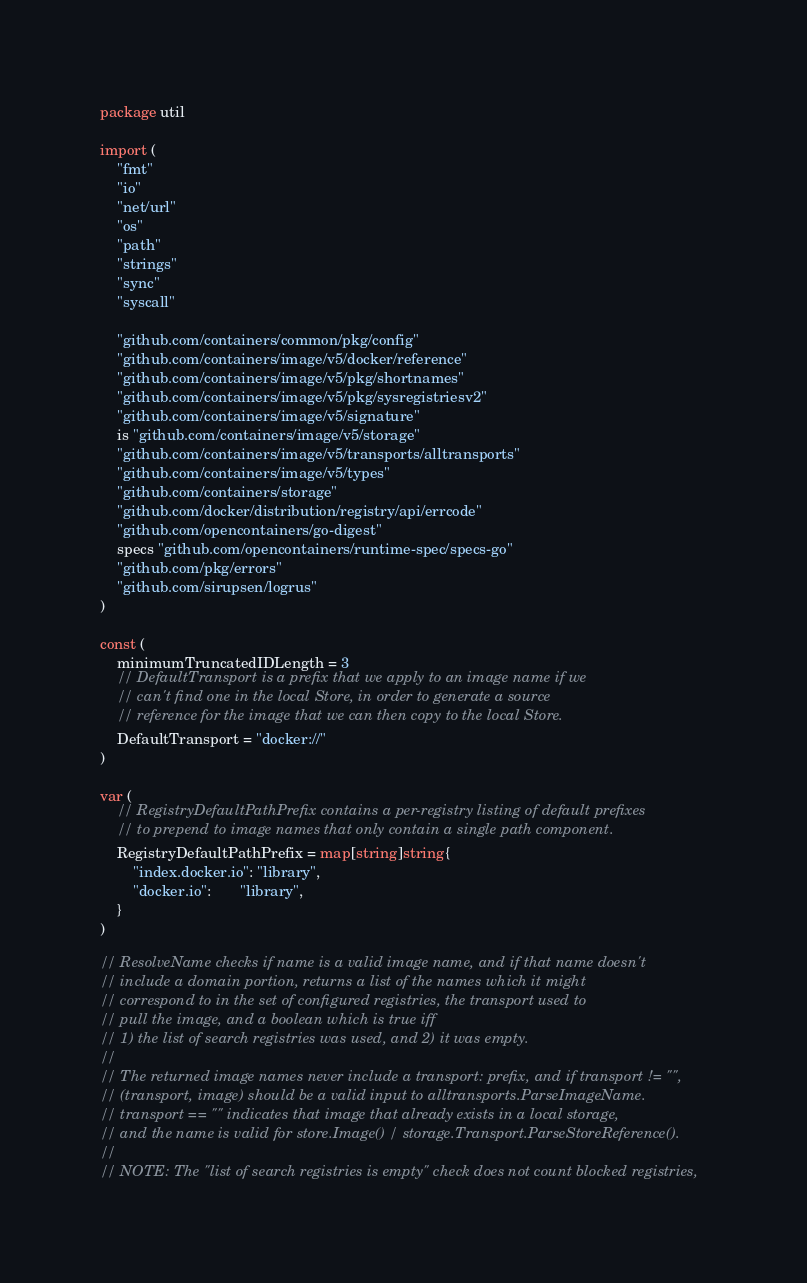<code> <loc_0><loc_0><loc_500><loc_500><_Go_>package util

import (
	"fmt"
	"io"
	"net/url"
	"os"
	"path"
	"strings"
	"sync"
	"syscall"

	"github.com/containers/common/pkg/config"
	"github.com/containers/image/v5/docker/reference"
	"github.com/containers/image/v5/pkg/shortnames"
	"github.com/containers/image/v5/pkg/sysregistriesv2"
	"github.com/containers/image/v5/signature"
	is "github.com/containers/image/v5/storage"
	"github.com/containers/image/v5/transports/alltransports"
	"github.com/containers/image/v5/types"
	"github.com/containers/storage"
	"github.com/docker/distribution/registry/api/errcode"
	"github.com/opencontainers/go-digest"
	specs "github.com/opencontainers/runtime-spec/specs-go"
	"github.com/pkg/errors"
	"github.com/sirupsen/logrus"
)

const (
	minimumTruncatedIDLength = 3
	// DefaultTransport is a prefix that we apply to an image name if we
	// can't find one in the local Store, in order to generate a source
	// reference for the image that we can then copy to the local Store.
	DefaultTransport = "docker://"
)

var (
	// RegistryDefaultPathPrefix contains a per-registry listing of default prefixes
	// to prepend to image names that only contain a single path component.
	RegistryDefaultPathPrefix = map[string]string{
		"index.docker.io": "library",
		"docker.io":       "library",
	}
)

// ResolveName checks if name is a valid image name, and if that name doesn't
// include a domain portion, returns a list of the names which it might
// correspond to in the set of configured registries, the transport used to
// pull the image, and a boolean which is true iff
// 1) the list of search registries was used, and 2) it was empty.
//
// The returned image names never include a transport: prefix, and if transport != "",
// (transport, image) should be a valid input to alltransports.ParseImageName.
// transport == "" indicates that image that already exists in a local storage,
// and the name is valid for store.Image() / storage.Transport.ParseStoreReference().
//
// NOTE: The "list of search registries is empty" check does not count blocked registries,</code> 